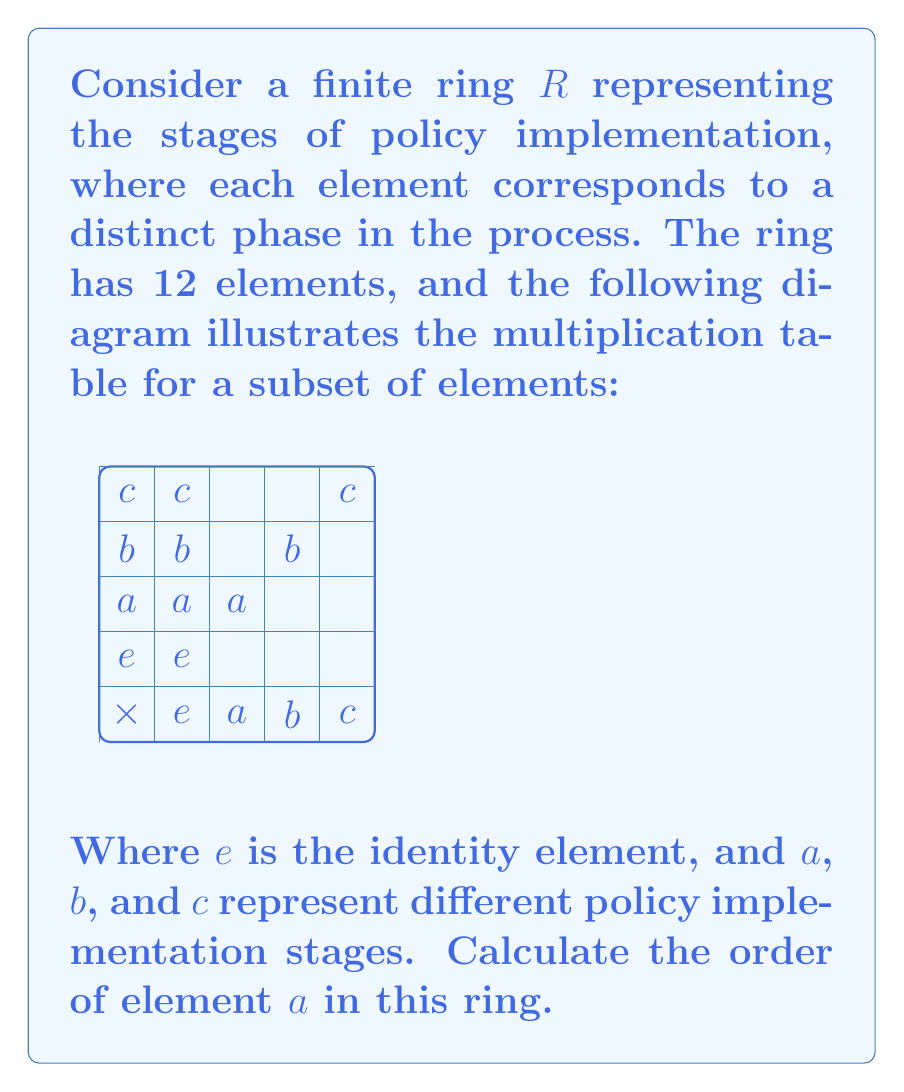Show me your answer to this math problem. To calculate the order of element $a$ in the finite ring $R$, we need to determine the smallest positive integer $n$ such that $a^n = e$, where $e$ is the identity element. Let's approach this step-by-step:

1) First, let's compute the powers of $a$:

   $a^1 = a$
   $a^2 = a \times a = a$ (from the multiplication table)
   $a^3 = a \times a^2 = a \times a = a$

2) We observe that $a^2 = a$, which means that $a$ is idempotent.

3) This implies that for any positive integer $k$, $a^k = a$.

4) However, the order of an element is defined as the smallest positive integer $n$ such that $a^n = e$, not just when the element starts repeating.

5) From the given information, we can see that $a \neq e$.

6) Since the ring has 12 elements, by Lagrange's theorem, the order of any element must divide 12.

7) The possible orders are thus 1, 2, 3, 4, 6, or 12.

8) We've already established that $a^k = a$ for all positive integers $k$, which means $a$ never equals $e$ for any finite power.

9) In ring theory, an element that is not equal to the identity element and whose powers never equal the identity element is called a nilpotent element of infinite order.

Therefore, in this finite ring, element $a$ has infinite order, despite the ring itself being finite. This is a unique characteristic of rings compared to groups, where elements in a finite structure always have finite order.
Answer: $\infty$ (infinite order) 